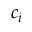Convert formula to latex. <formula><loc_0><loc_0><loc_500><loc_500>c _ { i }</formula> 